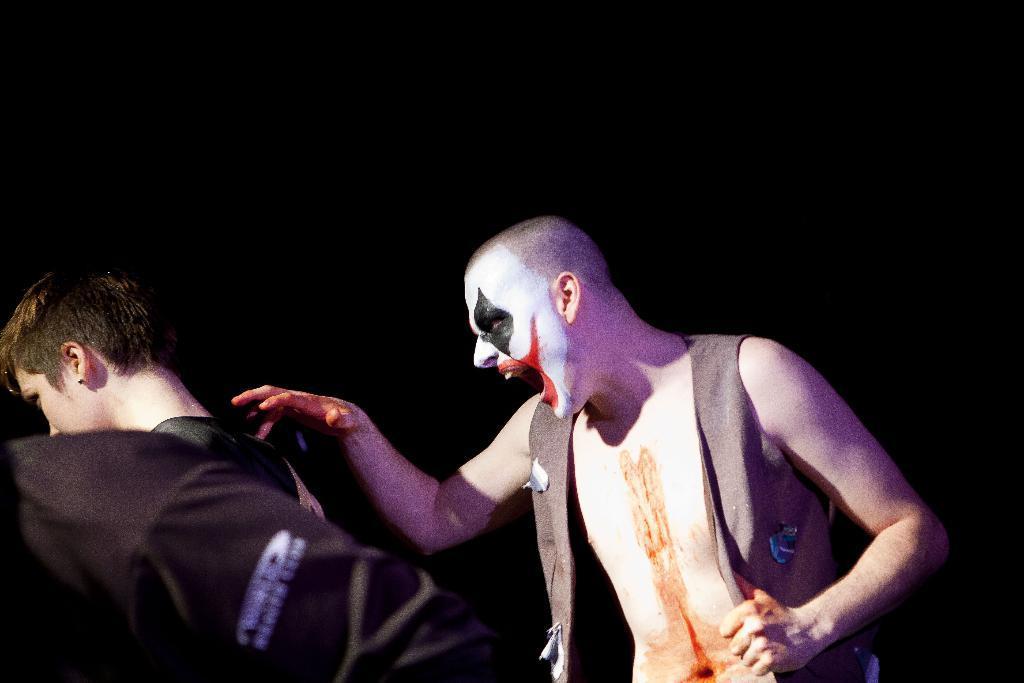Could you give a brief overview of what you see in this image? In this image we can see a person with a makeup. Also there are two other people. In the background it is dark. 